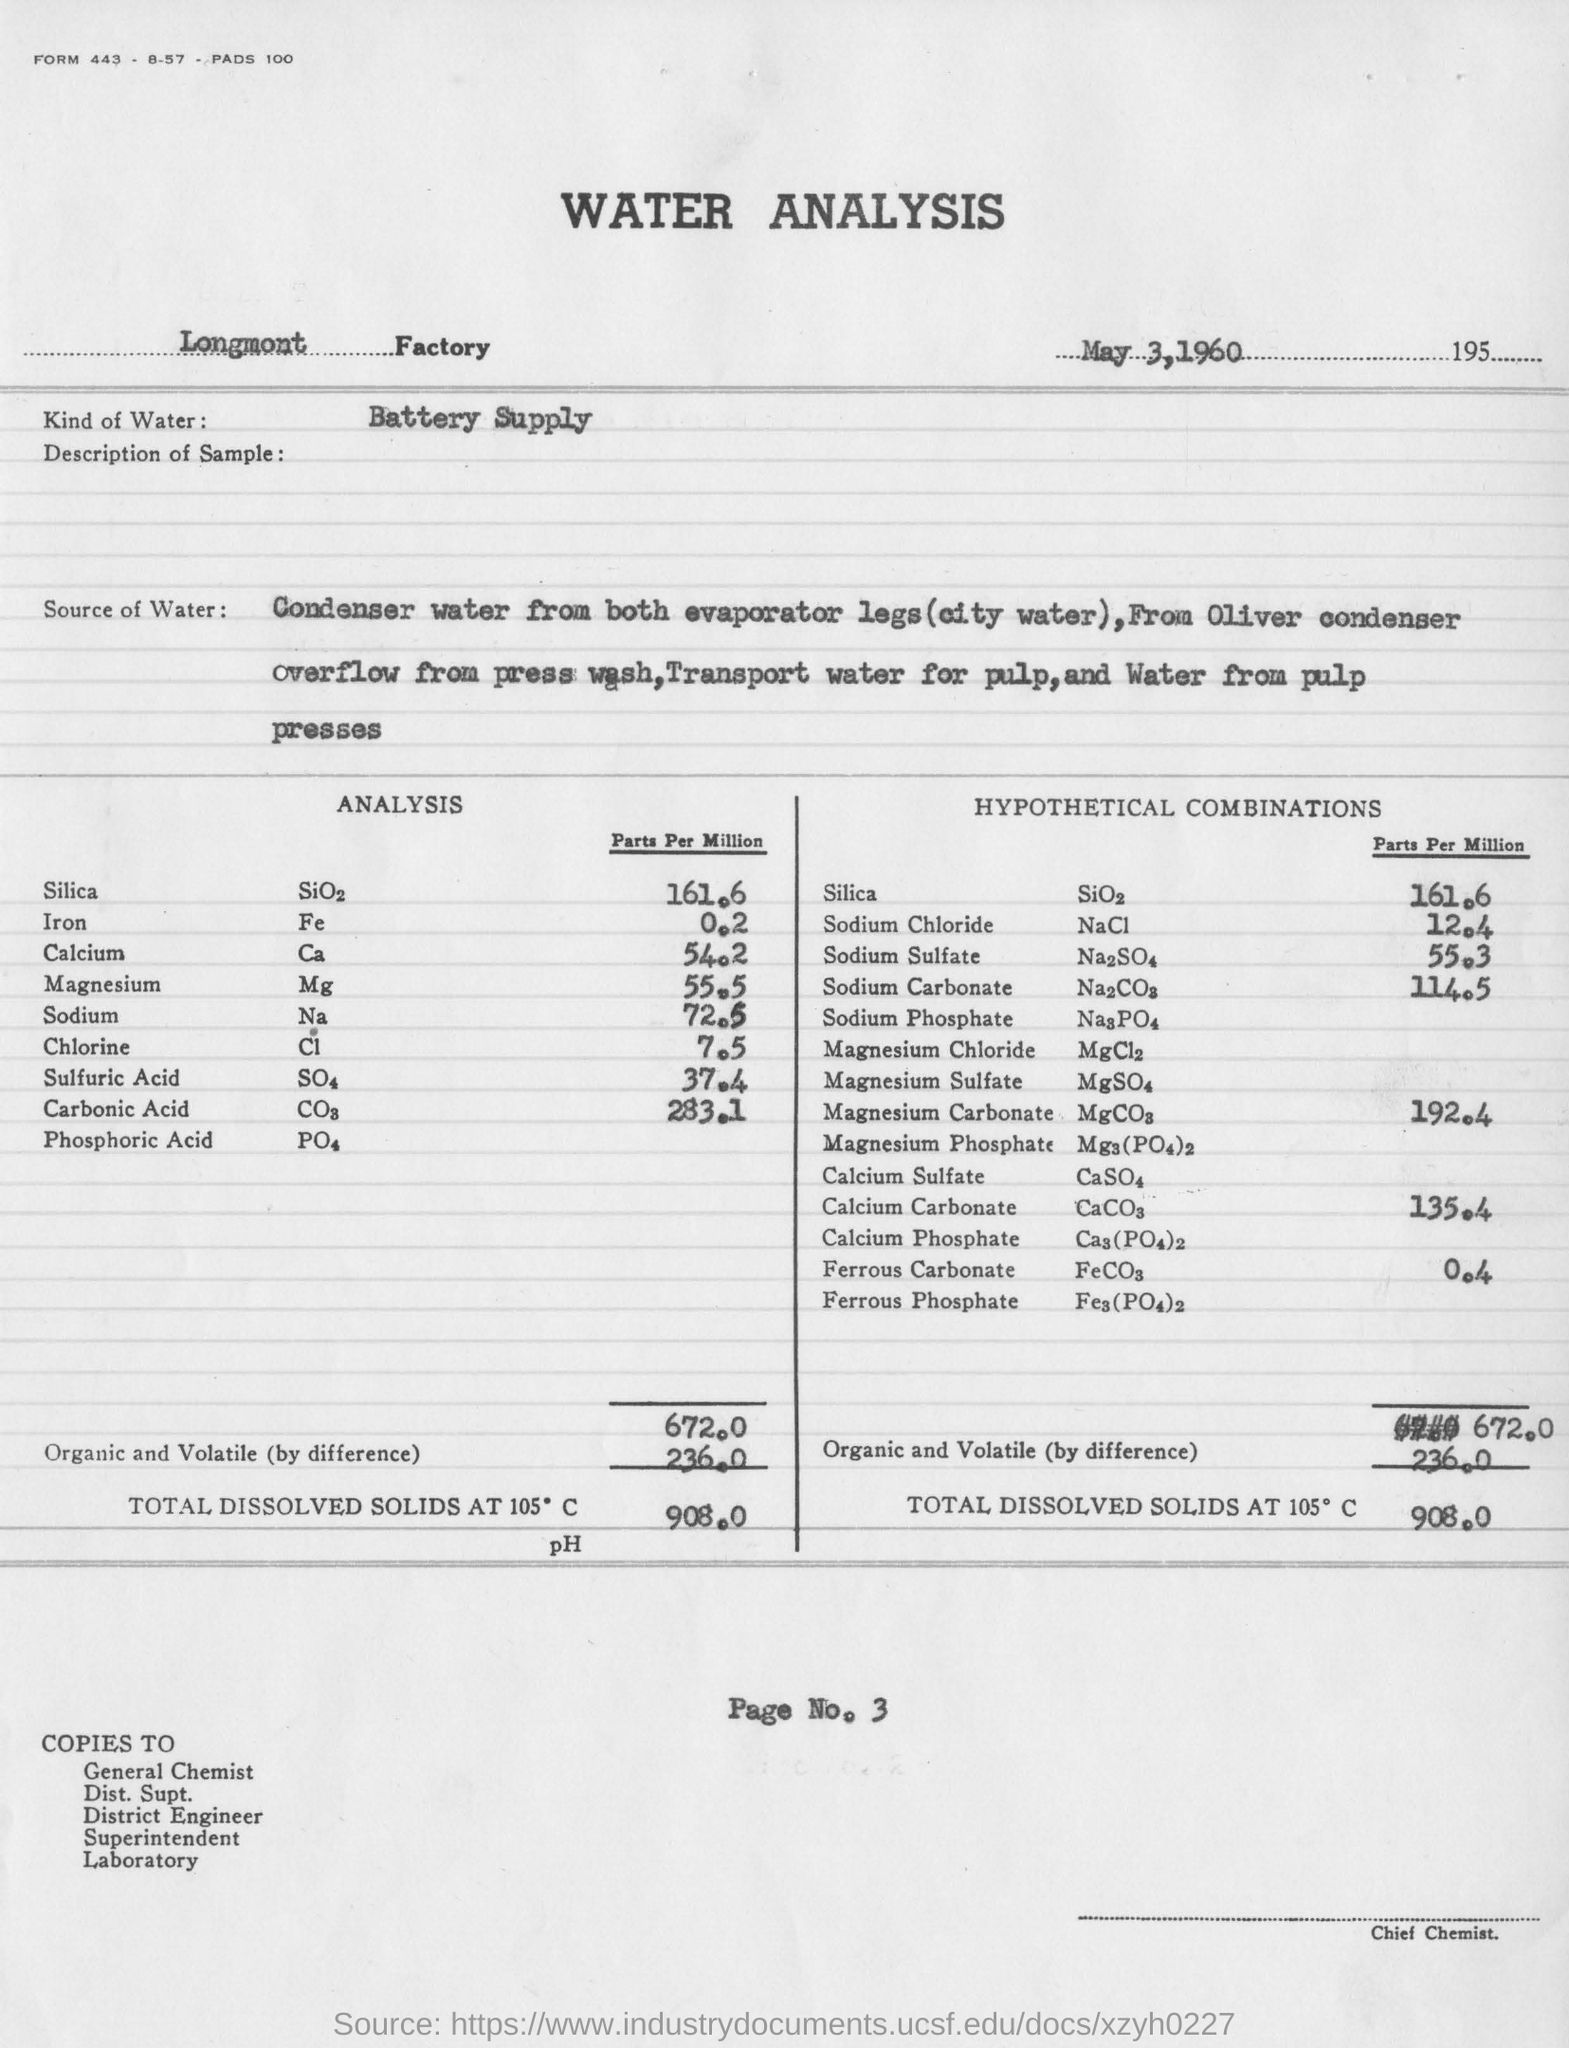Outline some significant characteristics in this image. The report was created on May 3, 1960. There is a type of water known as battery supply water that is particularly useful for certain applications. 